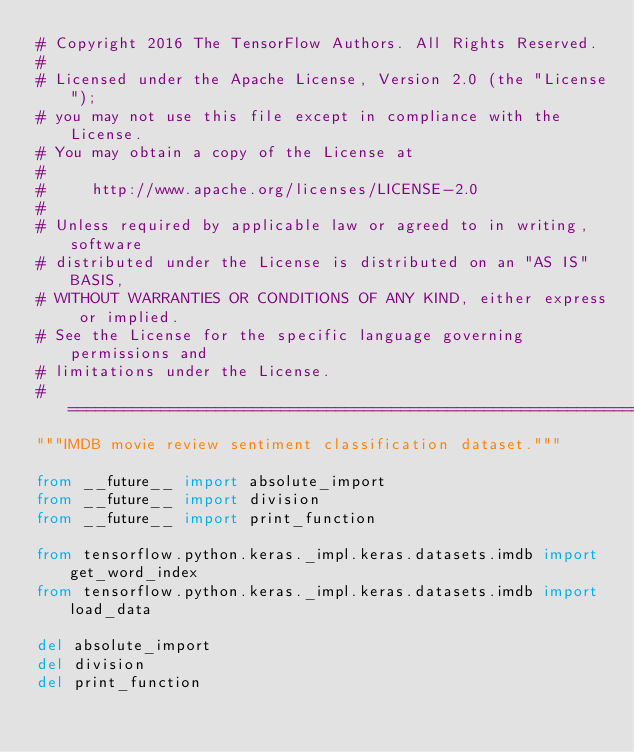Convert code to text. <code><loc_0><loc_0><loc_500><loc_500><_Python_># Copyright 2016 The TensorFlow Authors. All Rights Reserved.
#
# Licensed under the Apache License, Version 2.0 (the "License");
# you may not use this file except in compliance with the License.
# You may obtain a copy of the License at
#
#     http://www.apache.org/licenses/LICENSE-2.0
#
# Unless required by applicable law or agreed to in writing, software
# distributed under the License is distributed on an "AS IS" BASIS,
# WITHOUT WARRANTIES OR CONDITIONS OF ANY KIND, either express or implied.
# See the License for the specific language governing permissions and
# limitations under the License.
# ==============================================================================
"""IMDB movie review sentiment classification dataset."""

from __future__ import absolute_import
from __future__ import division
from __future__ import print_function

from tensorflow.python.keras._impl.keras.datasets.imdb import get_word_index
from tensorflow.python.keras._impl.keras.datasets.imdb import load_data

del absolute_import
del division
del print_function
</code> 